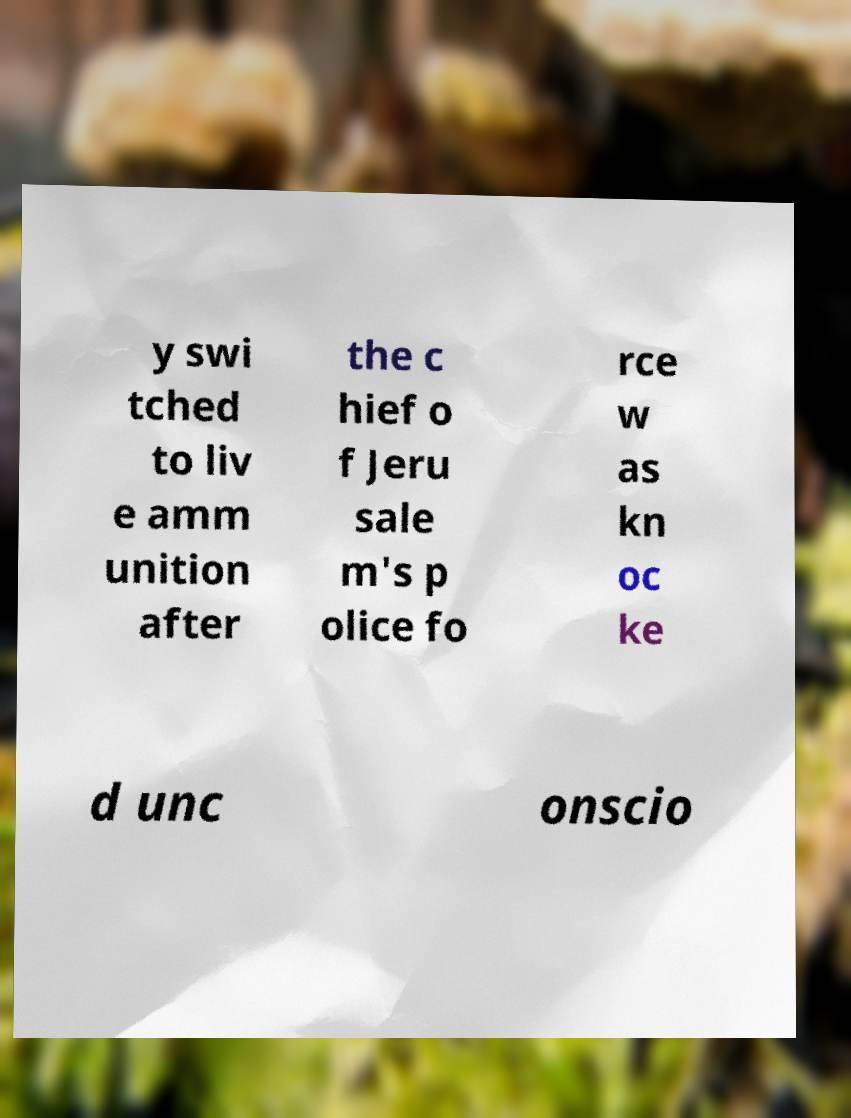Can you read and provide the text displayed in the image?This photo seems to have some interesting text. Can you extract and type it out for me? y swi tched to liv e amm unition after the c hief o f Jeru sale m's p olice fo rce w as kn oc ke d unc onscio 